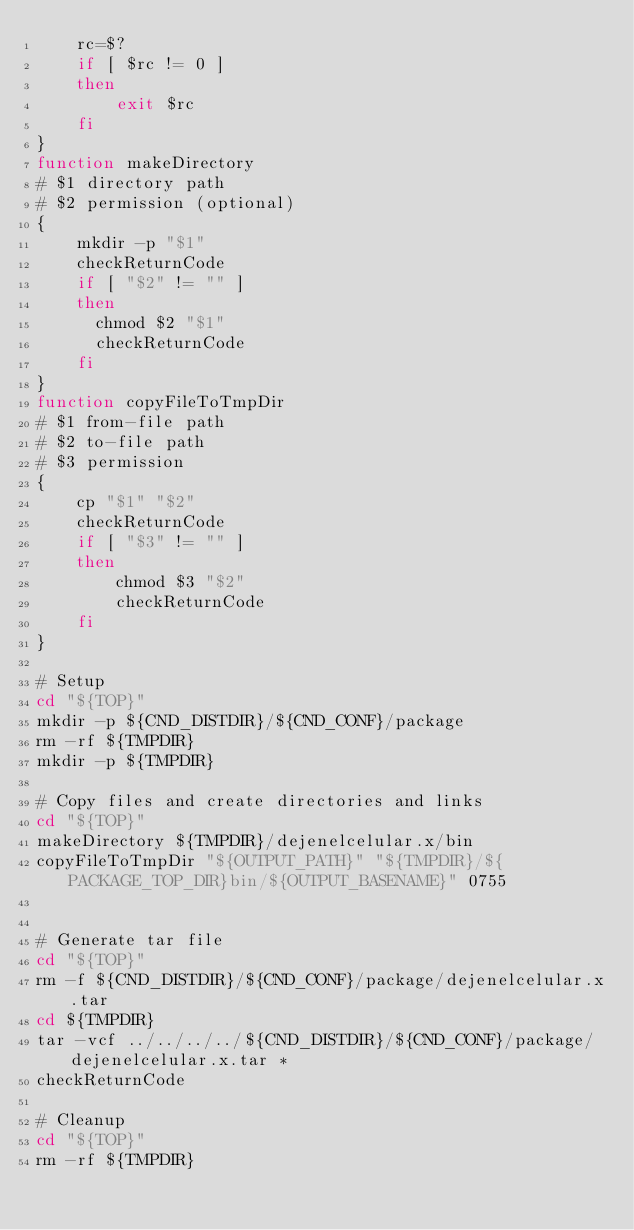Convert code to text. <code><loc_0><loc_0><loc_500><loc_500><_Bash_>    rc=$?
    if [ $rc != 0 ]
    then
        exit $rc
    fi
}
function makeDirectory
# $1 directory path
# $2 permission (optional)
{
    mkdir -p "$1"
    checkReturnCode
    if [ "$2" != "" ]
    then
      chmod $2 "$1"
      checkReturnCode
    fi
}
function copyFileToTmpDir
# $1 from-file path
# $2 to-file path
# $3 permission
{
    cp "$1" "$2"
    checkReturnCode
    if [ "$3" != "" ]
    then
        chmod $3 "$2"
        checkReturnCode
    fi
}

# Setup
cd "${TOP}"
mkdir -p ${CND_DISTDIR}/${CND_CONF}/package
rm -rf ${TMPDIR}
mkdir -p ${TMPDIR}

# Copy files and create directories and links
cd "${TOP}"
makeDirectory ${TMPDIR}/dejenelcelular.x/bin
copyFileToTmpDir "${OUTPUT_PATH}" "${TMPDIR}/${PACKAGE_TOP_DIR}bin/${OUTPUT_BASENAME}" 0755


# Generate tar file
cd "${TOP}"
rm -f ${CND_DISTDIR}/${CND_CONF}/package/dejenelcelular.x.tar
cd ${TMPDIR}
tar -vcf ../../../../${CND_DISTDIR}/${CND_CONF}/package/dejenelcelular.x.tar *
checkReturnCode

# Cleanup
cd "${TOP}"
rm -rf ${TMPDIR}
</code> 